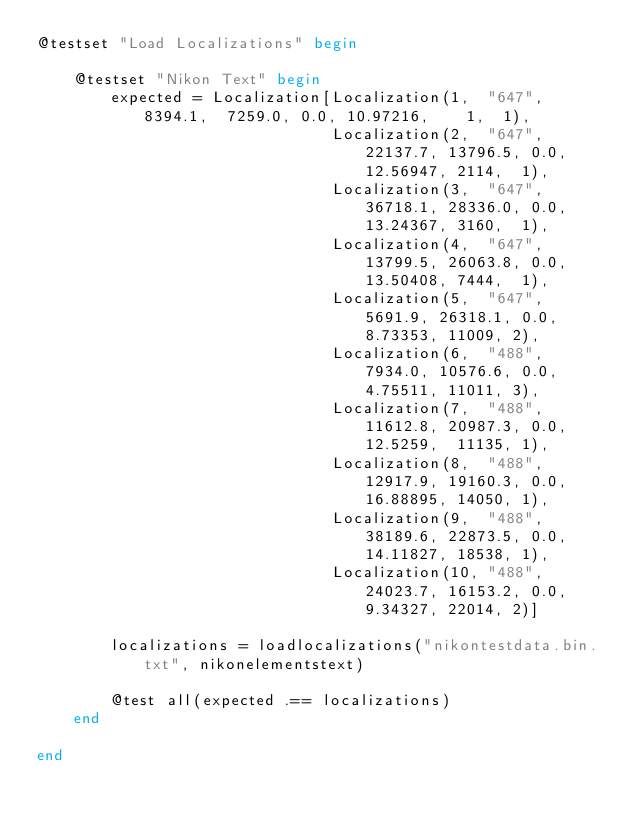Convert code to text. <code><loc_0><loc_0><loc_500><loc_500><_Julia_>@testset "Load Localizations" begin

    @testset "Nikon Text" begin
        expected = Localization[Localization(1,  "647",  8394.1,  7259.0, 0.0, 10.97216,    1,  1),
                                Localization(2,  "647", 22137.7, 13796.5, 0.0, 12.56947, 2114,  1),
                                Localization(3,  "647", 36718.1, 28336.0, 0.0, 13.24367, 3160,  1),
                                Localization(4,  "647", 13799.5, 26063.8, 0.0, 13.50408, 7444,  1),
                                Localization(5,  "647",  5691.9, 26318.1, 0.0,  8.73353, 11009, 2),
                                Localization(6,  "488",  7934.0, 10576.6, 0.0,  4.75511, 11011, 3),
                                Localization(7,  "488", 11612.8, 20987.3, 0.0, 12.5259,  11135, 1),
                                Localization(8,  "488", 12917.9, 19160.3, 0.0, 16.88895, 14050, 1),
                                Localization(9,  "488", 38189.6, 22873.5, 0.0, 14.11827, 18538, 1),
                                Localization(10, "488", 24023.7, 16153.2, 0.0,  9.34327, 22014, 2)]

        localizations = loadlocalizations("nikontestdata.bin.txt", nikonelementstext)

        @test all(expected .== localizations)
    end

end
</code> 